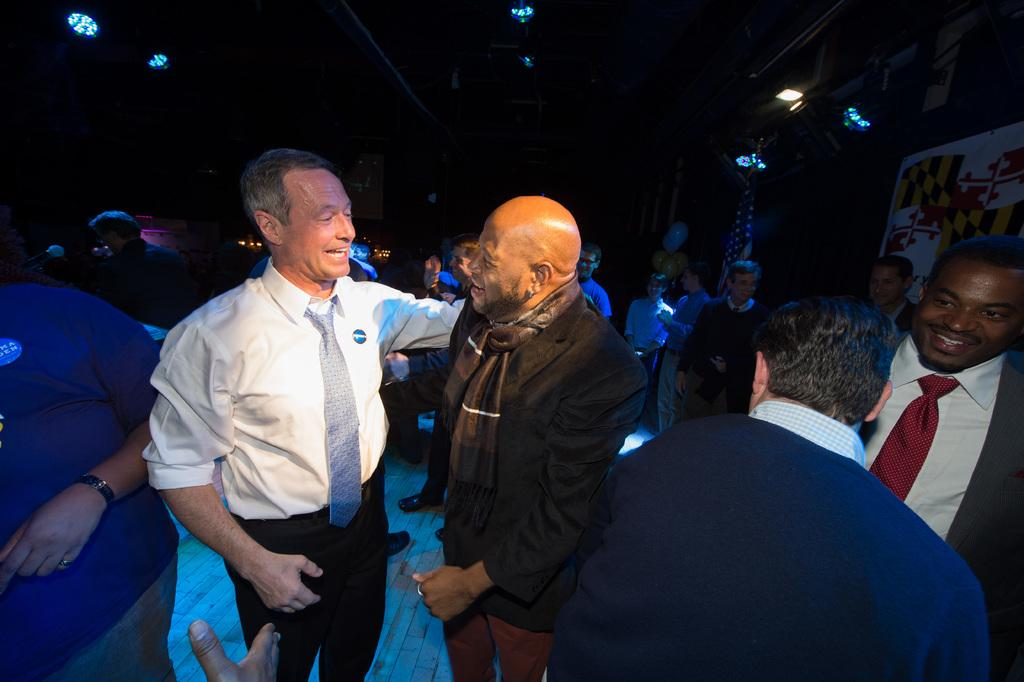What can be seen on both sides of the image? There are people on both the right and left sides of the image. What is located on the right side of the image besides the people? There is a poster on the right side of the image. What is visible at the top side of the image? There are lights at the top side of the image. What type of skin is visible on the people in the image? There is no specific mention of the skin of the people in the image, and it cannot be determined from the image alone. 